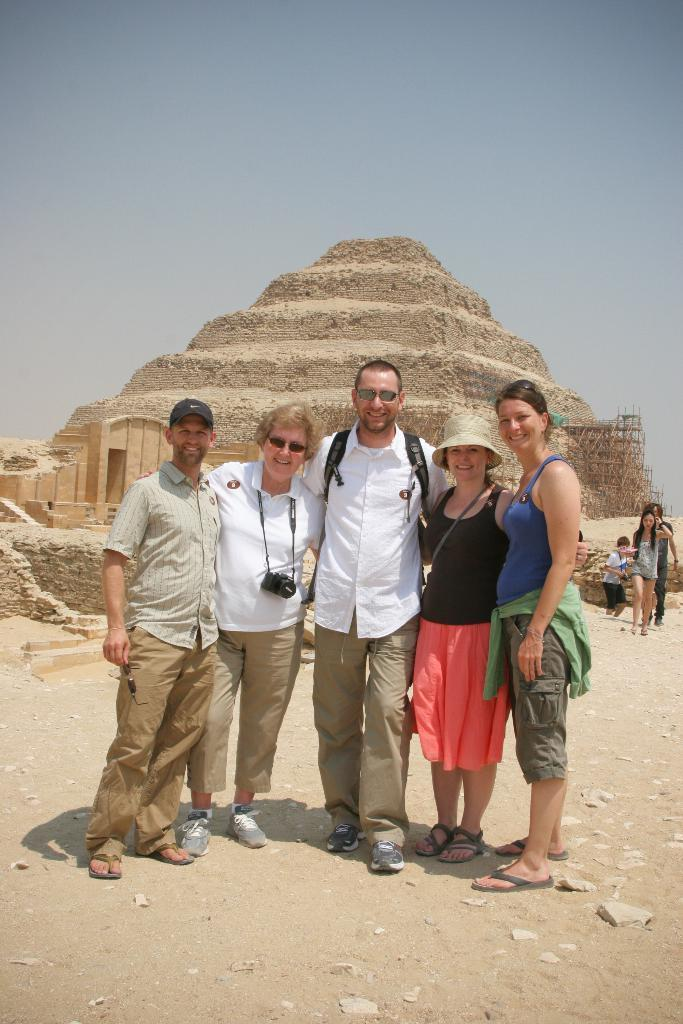What is happening with the group of people in the image? The group of men and women is standing and posing for the camera. What can be seen in the background of the image? There is a pyramid in the background of the image. What is visible at the top of the image? The sky is visible at the top of the image. What type of clocks are the people reading in the image? There are no clocks present in the image, and the people are not reading anything. What is the distance between the group of people and the pyramid in the image? The provided facts do not give information about the distance between the group and the pyramid, so it cannot be determined from the image. 